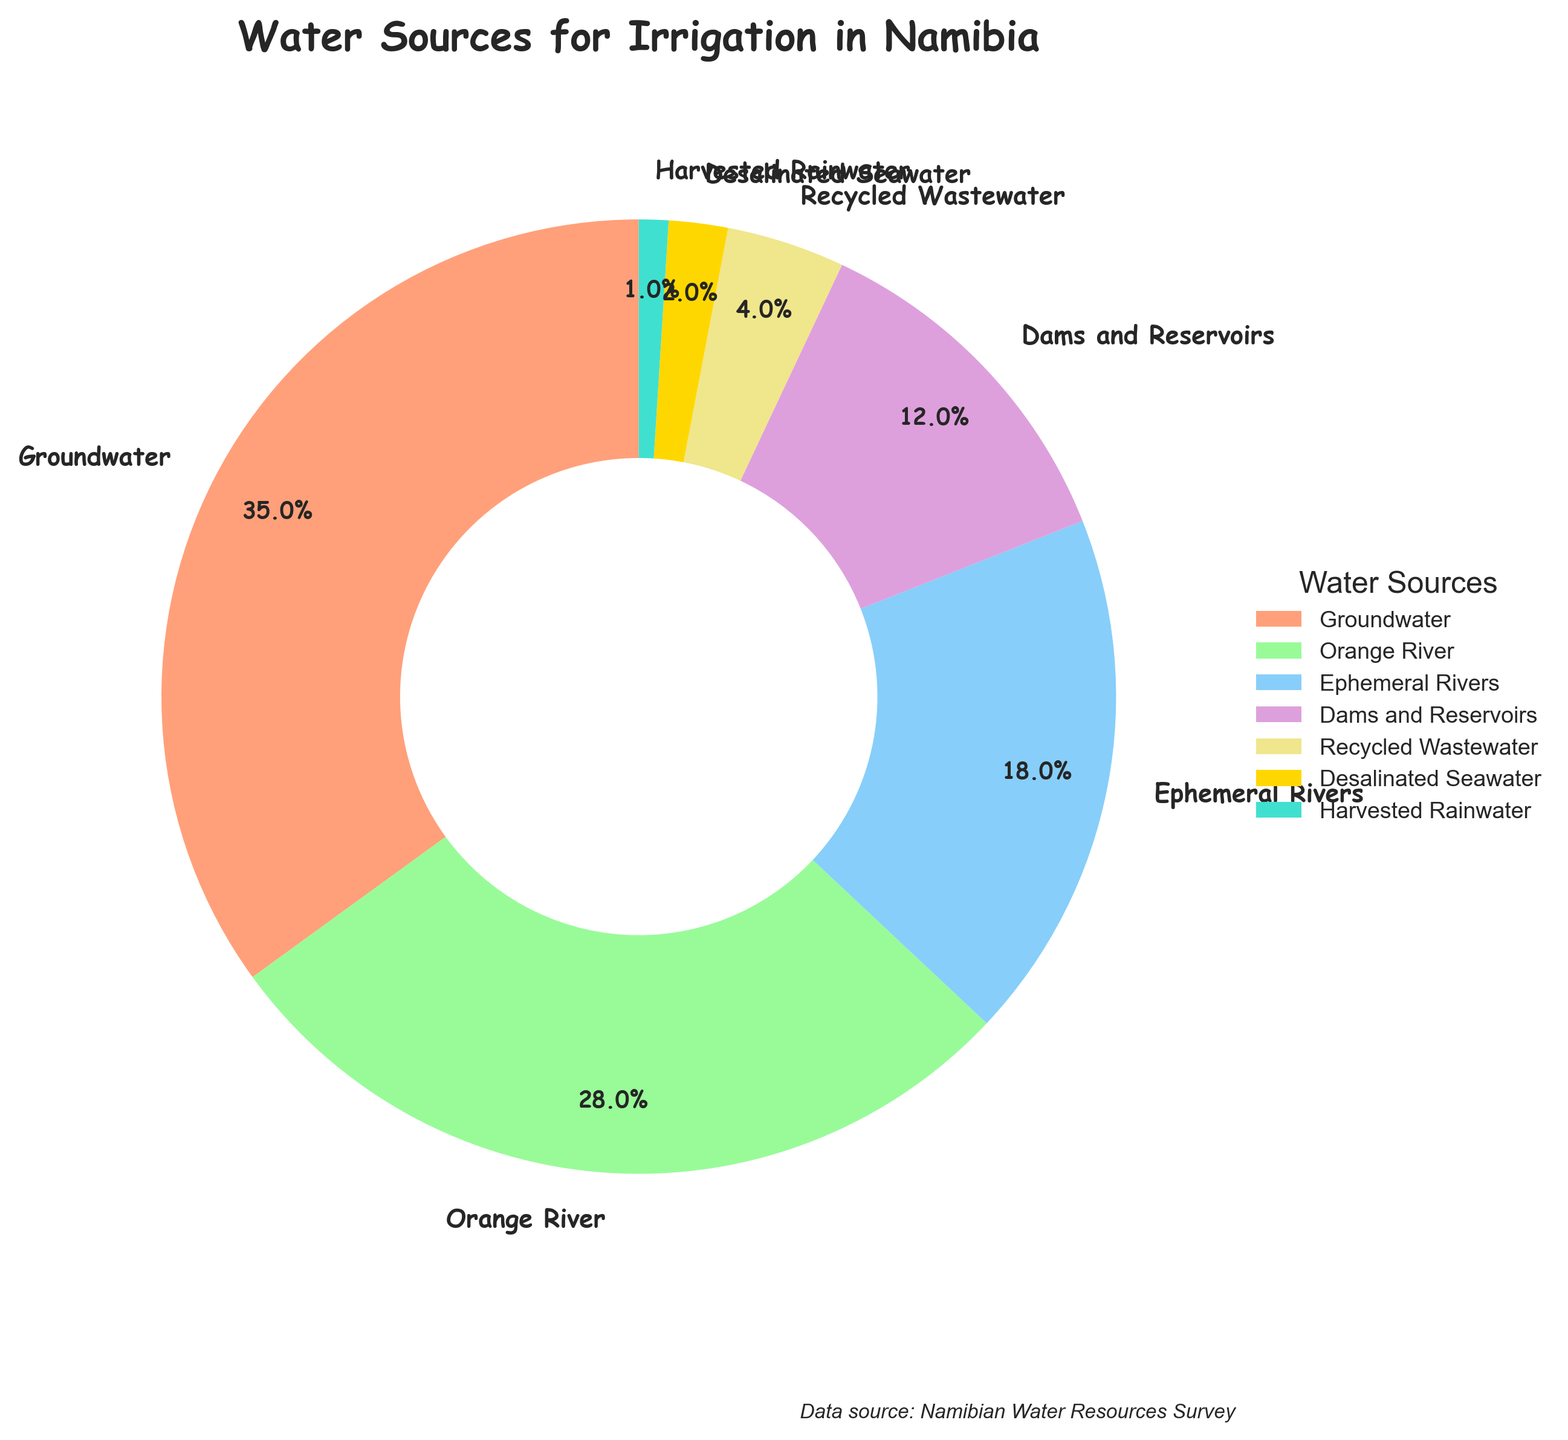Which water source is used the most for irrigation in Namibia? The pie chart shows that the sector with the largest slice is Groundwater. This indicates that Groundwater is used the most for irrigation.
Answer: Groundwater Which three water sources combined contribute over 50% of the water used for irrigation? Groundwater (35%), Orange River (28%), and Ephemeral Rivers (18%) need to be summed up to check if their total exceeds 50%. Sum: 35 + 28 + 18 = 81%. This combination is well over 50%.
Answer: Groundwater, Orange River, and Ephemeral Rivers What is the difference in the percentage of water used between the Orange River and Ephemeral Rivers? The percentage for the Orange River is 28%, and for Ephemeral Rivers, it is 18%. The difference is calculated by subtracting the smaller percentage from the larger one: 28 - 18 = 10%.
Answer: 10% By how much does the percentage of recycled wastewater and desalinated seawater combined fall short of that of dams and reservoirs? Recycled Wastewater contributes 4%, and Desalinated Seawater contributes 2%. Their combined percentage is 4 + 2 = 6%. The percentage for Dams and Reservoirs is 12%. The shortfall is therefore 12 - 6 = 6%.
Answer: 6% What is the total percentage of water used for irrigation by the least three contributing sources? The least three contributing sources are Desalinated Seawater (2%), Recycled Wastewater (4%), and Harvested Rainwater (1%). Their total is 2 + 4 + 1 = 7%.
Answer: 7% What is the combined percentage of water used from natural sources (Groundwater, Rivers, and Rainwater) for irrigation? Groundwater (35%), Orange River (28%), Ephemeral Rivers (18%), and Harvested Rainwater (1%) are natural sources. Sum them: 35 + 28 + 18 + 1 = 82%.
Answer: 82% Which water source has the smallest percentage, and what is its value? The pie chart shows that the smallest segment corresponds to Harvested Rainwater. Its percentage value is the smallest at 1%.
Answer: Harvested Rainwater, 1% How does the percentage of water used from dams and reservoirs compare with that of recycled wastewater? The percentage for Dams and Reservoirs is 12%, whereas Recycled Wastewater is 4%. Comparing both, the percentage of water from Dams and Reservoirs is greater than that from Recycled Wastewater.
Answer: Greater If 20% more water was sourced from the Orange River, what would the new percentage be? The current percentage for the Orange River is 28%. A 20% increase means calculating 20% of 28 and adding it to the original value: (0.20 * 28) + 28 = 5.6 + 28 = 33.6%.
Answer: 33.6% 